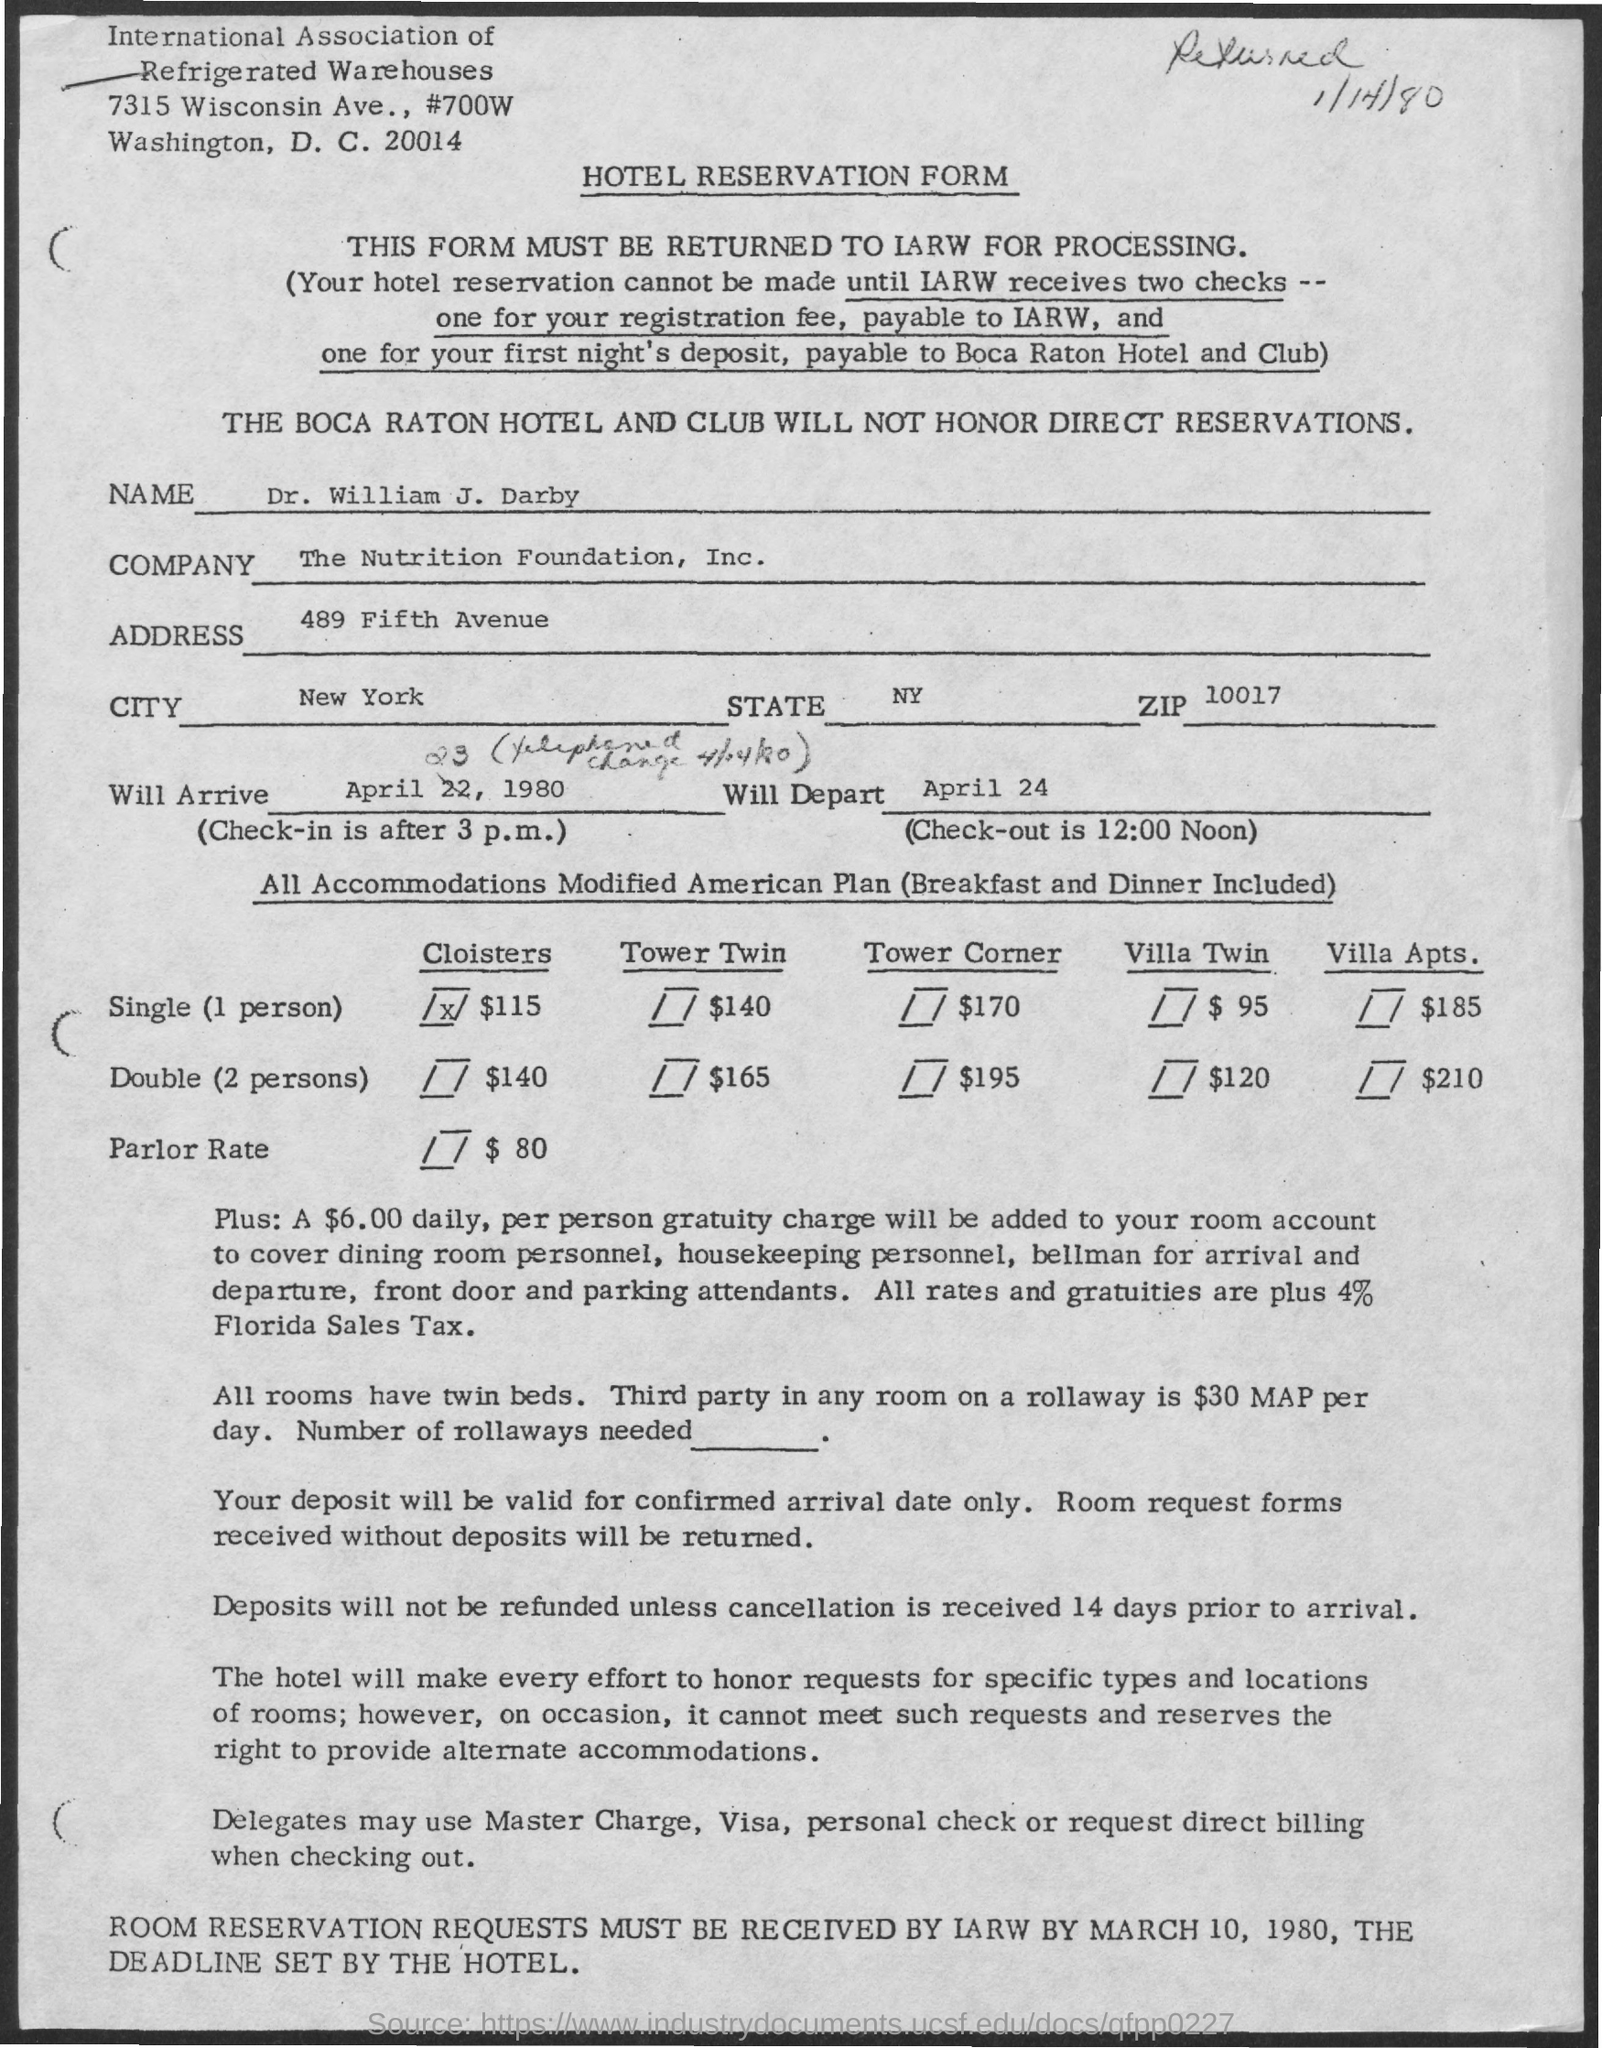What is the Title of the document?
Ensure brevity in your answer.  Hotel Reservation Form. What is the Name?
Offer a terse response. Dr. William J. Darby. What is the Company?
Offer a terse response. The Nutrition Foundation, Inc. What is the address?
Give a very brief answer. 489 Fifth Avenue. What is the City?
Provide a succinct answer. New York. What is the State?
Your answer should be compact. NY. When will he depart?
Your response must be concise. April 24. Till when the reservations cannot be made?
Provide a succinct answer. Until iarw receives two checks -- one for your registration fee, payable to iarw, and one for your first night's deposit, payable to boca raton hotel and club. 